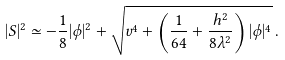<formula> <loc_0><loc_0><loc_500><loc_500>| S | ^ { 2 } \simeq - \frac { 1 } { 8 } | \phi | ^ { 2 } + \sqrt { v ^ { 4 } + \left ( \frac { 1 } { 6 4 } + \frac { h ^ { 2 } } { 8 \lambda ^ { 2 } } \right ) | \phi | ^ { 4 } } \, .</formula> 